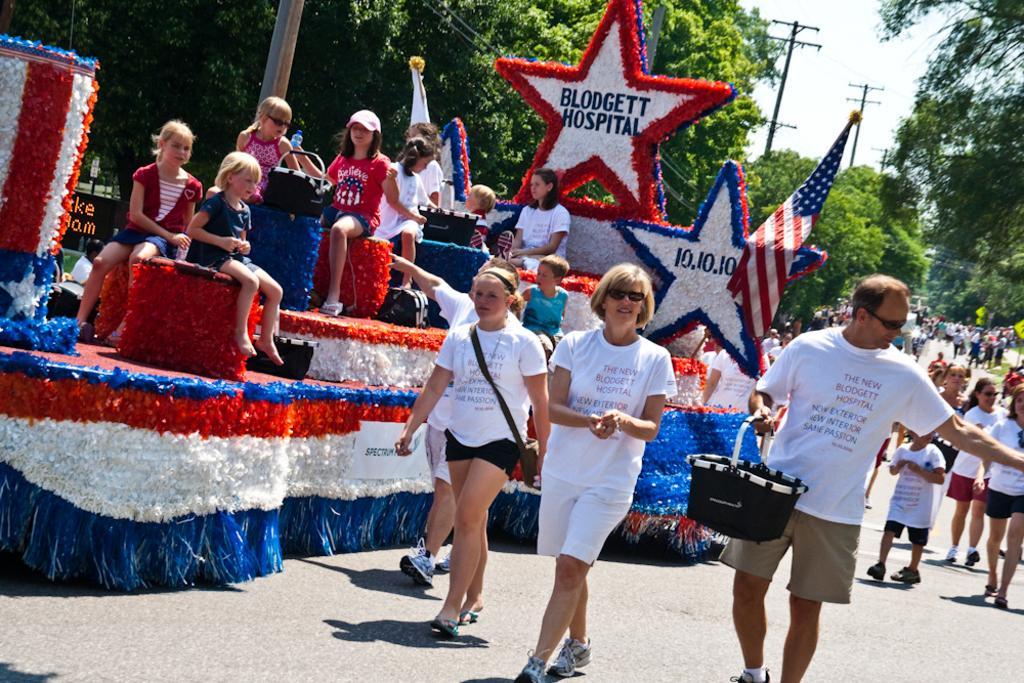How would you summarize this image in a sentence or two? This image consists of many people. In the front, the four people are wearing white T-shirts are walking. At the bottom, there is a road. In the background, there are trees. At the top, there is sky. On the left, we can see a dais along with a flag and children. 